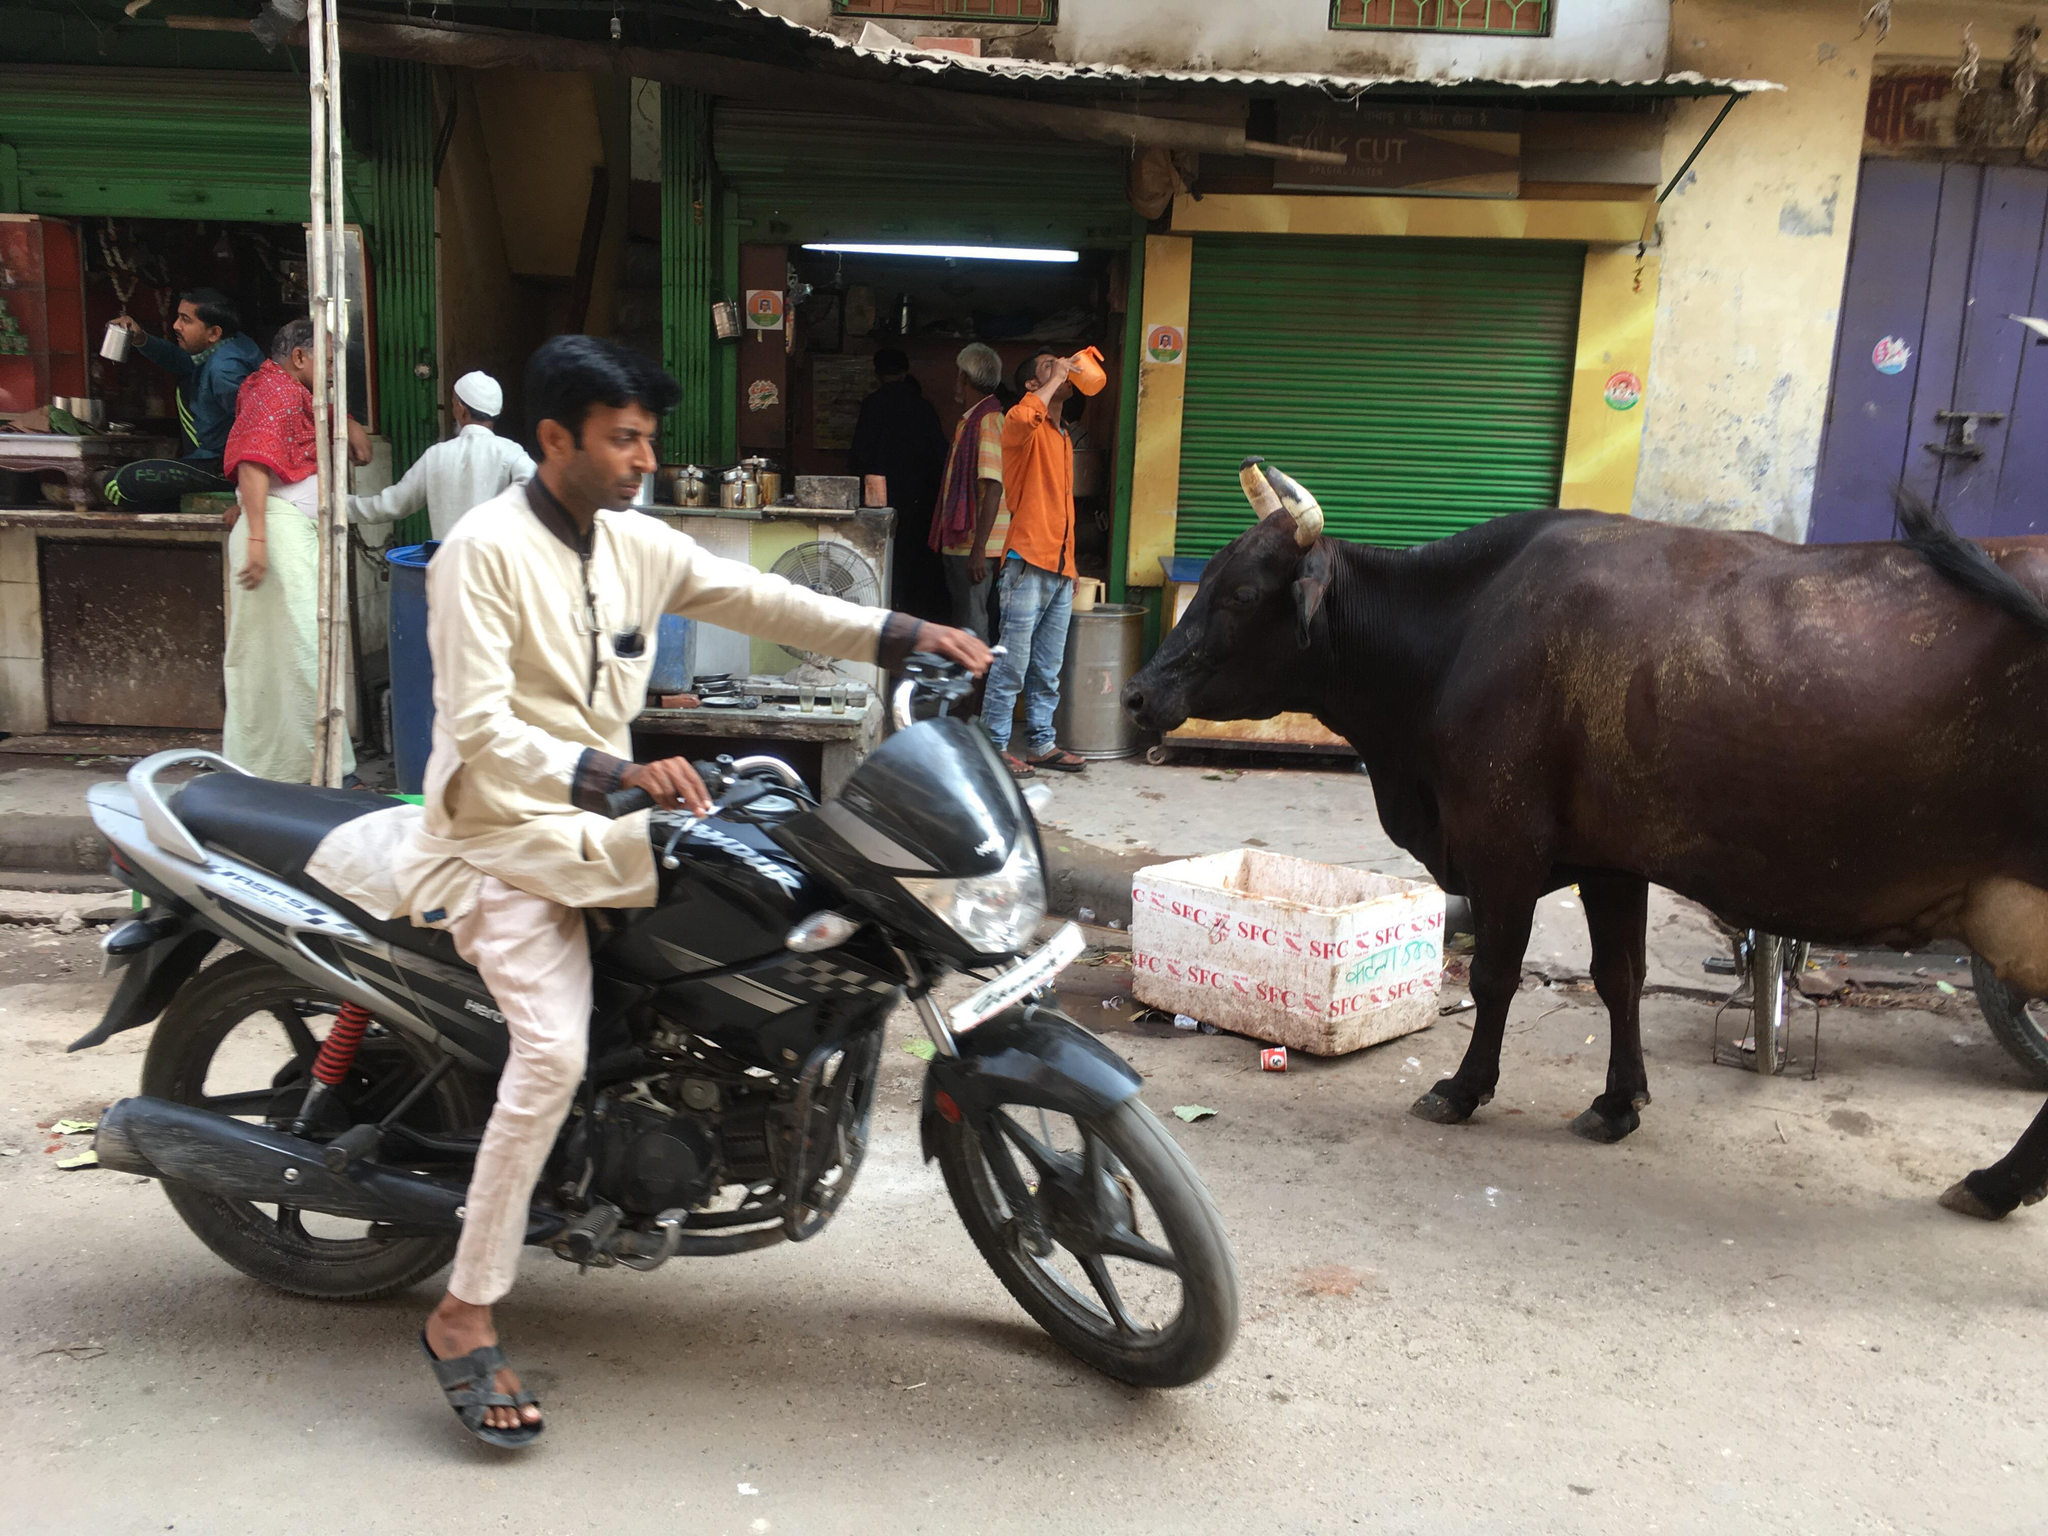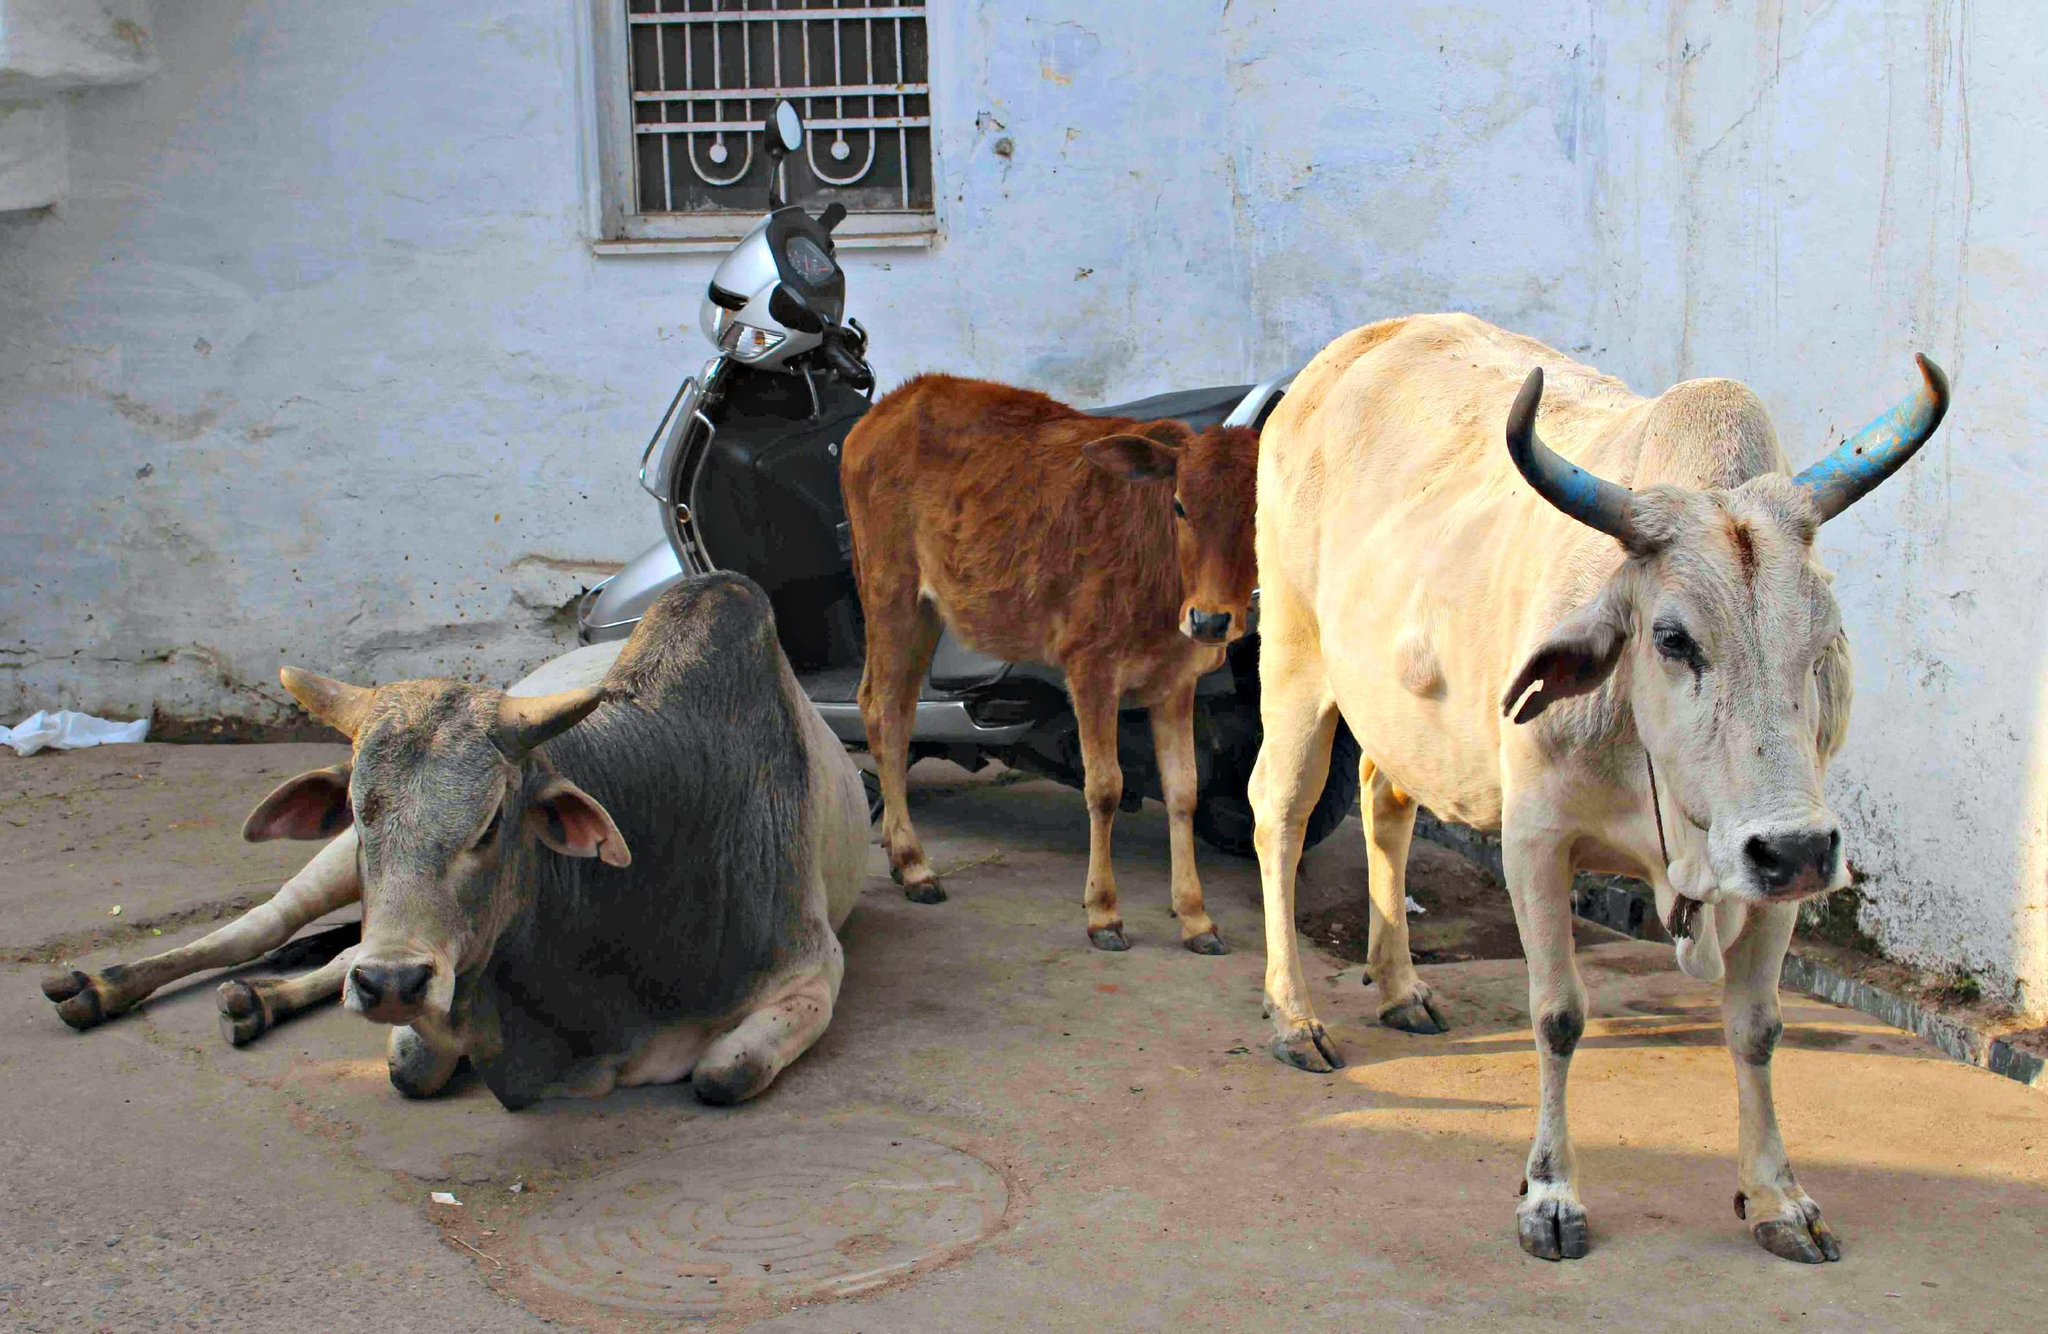The first image is the image on the left, the second image is the image on the right. Analyze the images presented: Is the assertion "There is at least one human visible." valid? Answer yes or no. Yes. The first image is the image on the left, the second image is the image on the right. For the images shown, is this caption "there are some oxen in water." true? Answer yes or no. No. 